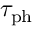Convert formula to latex. <formula><loc_0><loc_0><loc_500><loc_500>\tau _ { p h }</formula> 